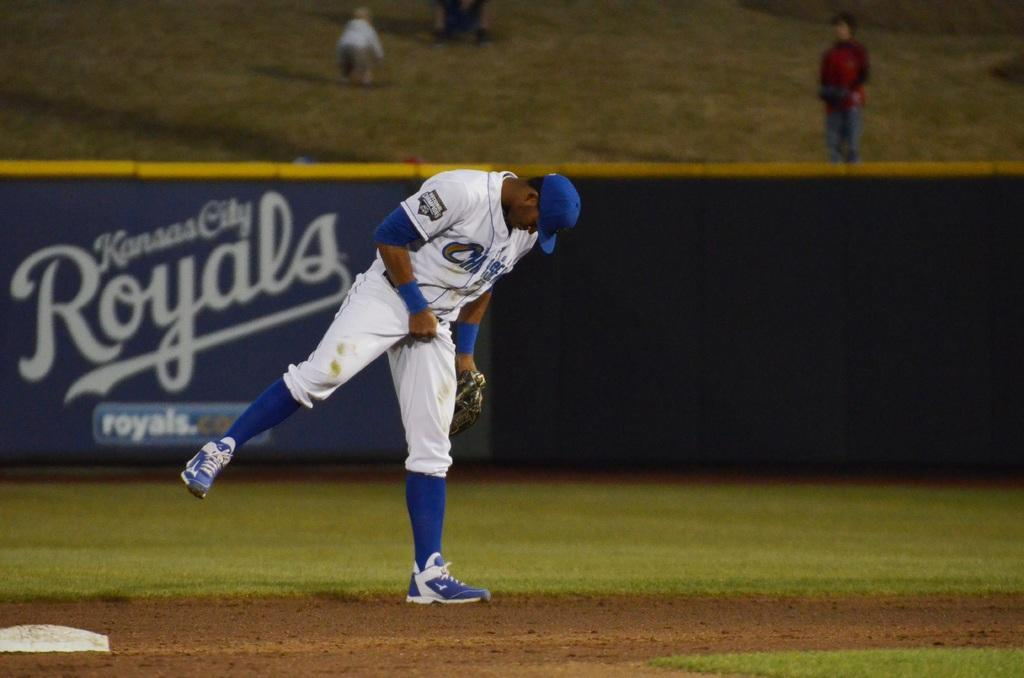<image>
Share a concise interpretation of the image provided. a player with a Royals advertisement far behind him 